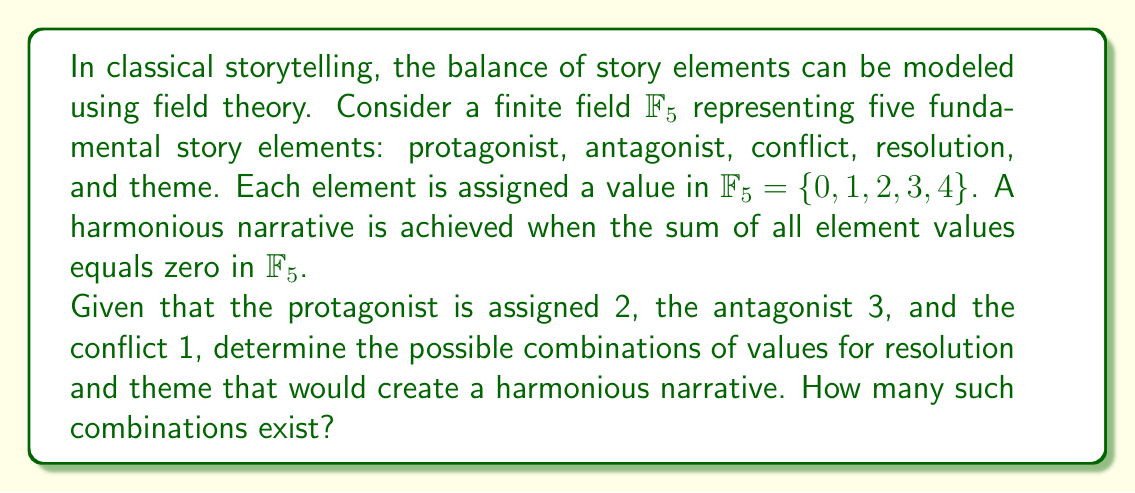Could you help me with this problem? Let's approach this step-by-step:

1) In $\mathbb{F}_5$, addition is performed modulo 5. We need the sum of all five elements to be congruent to 0 mod 5.

2) We are given:
   Protagonist (P) = 2
   Antagonist (A) = 3
   Conflict (C) = 1

3) Let's denote:
   Resolution (R) = x
   Theme (T) = y

4) For a harmonious narrative, we need:

   $$(P + A + C + R + T) \equiv 0 \pmod{5}$$

5) Substituting the known values:

   $$(2 + 3 + 1 + x + y) \equiv 0 \pmod{5}$$

6) Simplifying:

   $$(6 + x + y) \equiv 0 \pmod{5}$$
   $$(1 + x + y) \equiv 0 \pmod{5}$$

7) Solving for y:

   $$y \equiv -1 - x \pmod{5}$$
   $$y \equiv 4 - x \pmod{5}$$

8) Now, we can find the possible combinations:
   
   If x = 0, then y = 4
   If x = 1, then y = 3
   If x = 2, then y = 2
   If x = 3, then y = 1
   If x = 4, then y = 0

Therefore, there are 5 possible combinations of values for resolution and theme that create a harmonious narrative.
Answer: There are 5 possible combinations of values for resolution and theme that create a harmonious narrative in $\mathbb{F}_5$. 